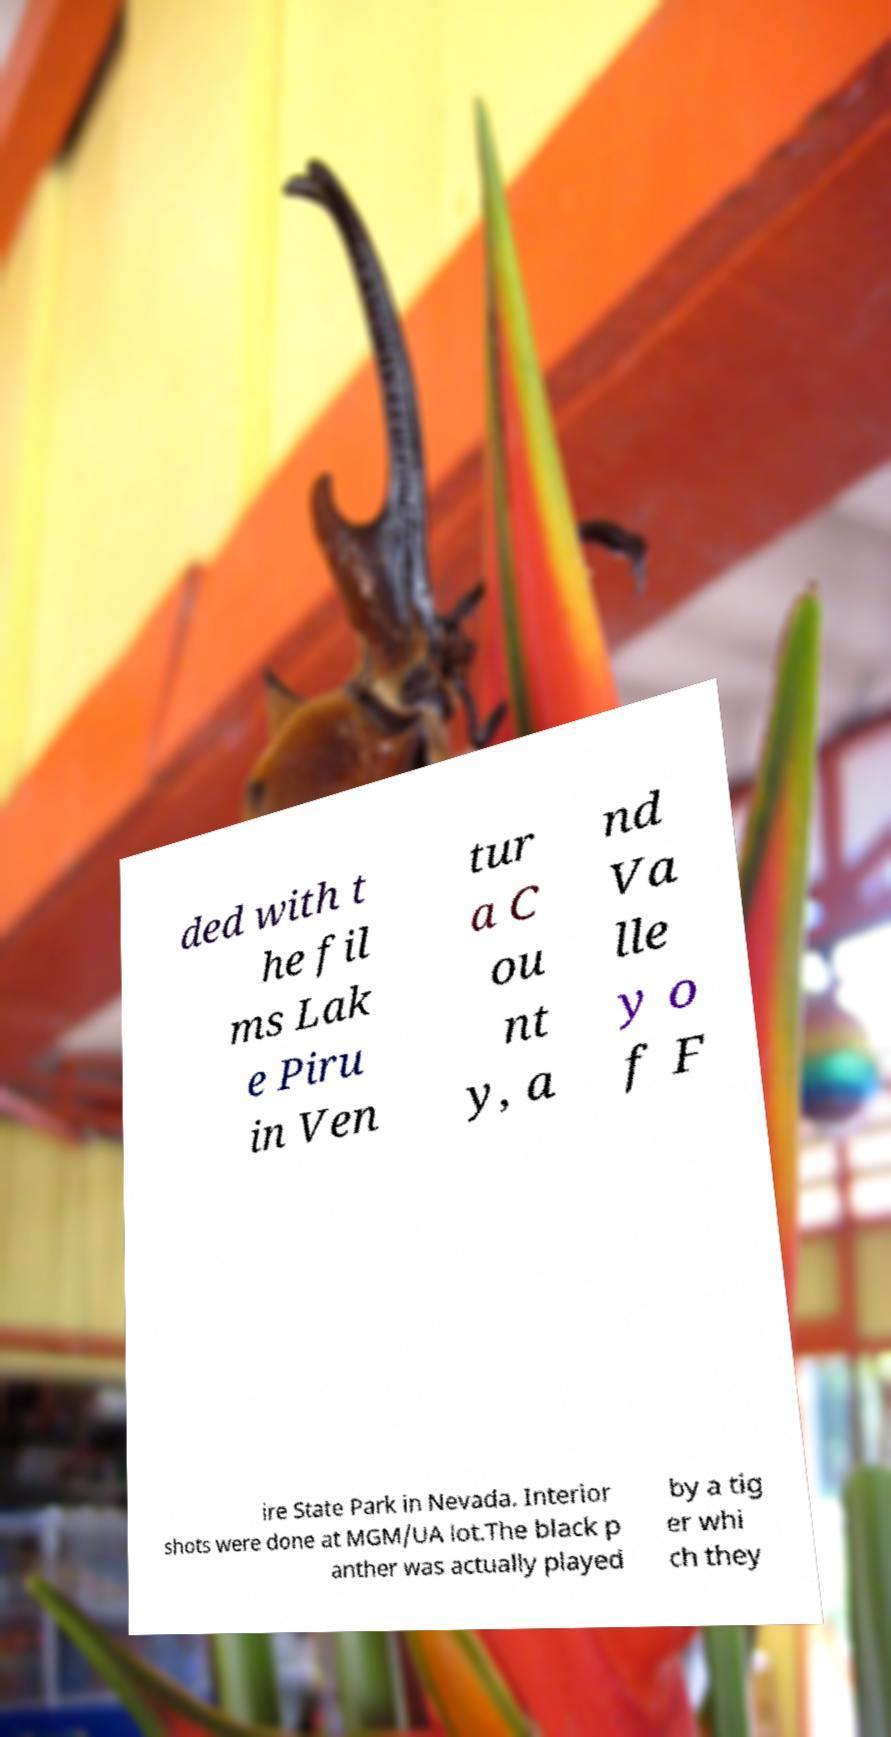What messages or text are displayed in this image? I need them in a readable, typed format. ded with t he fil ms Lak e Piru in Ven tur a C ou nt y, a nd Va lle y o f F ire State Park in Nevada. Interior shots were done at MGM/UA lot.The black p anther was actually played by a tig er whi ch they 